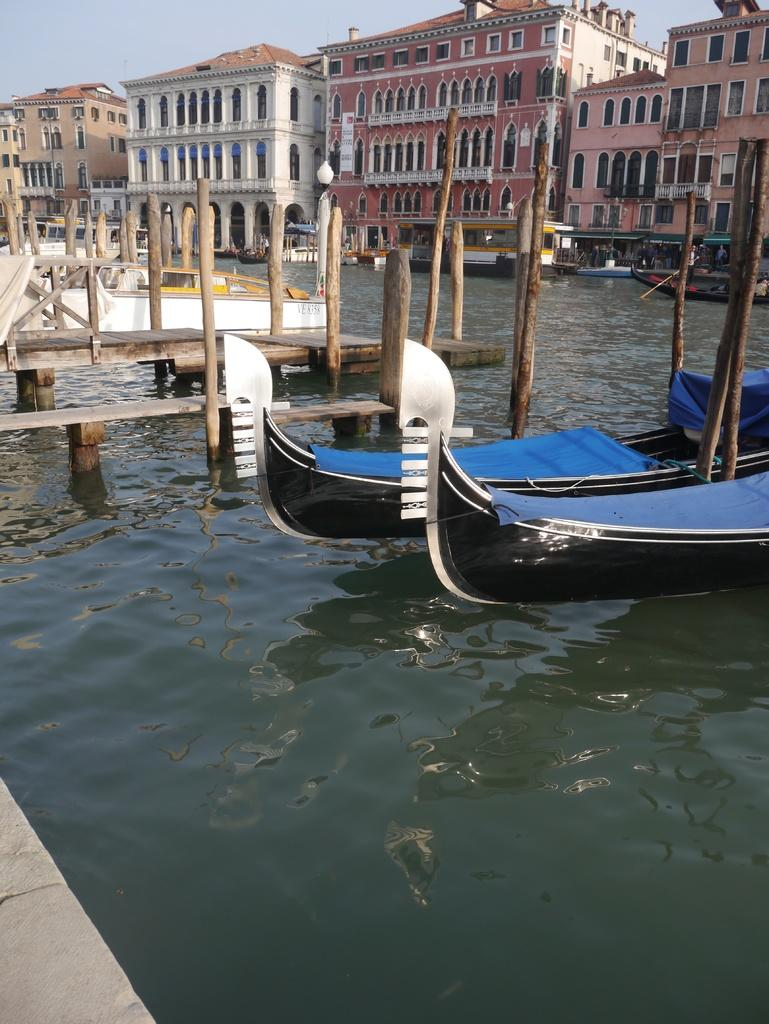What is floating on the water in the image? There are boats floating on the water in the image. What structure can be seen crossing the water in the image? There is a wooden bridge in the image. What can be seen in the distance in the image? There are buildings visible in the background of the image. What else is visible in the background of the image? The sky is visible in the background of the image. What type of loaf is being used to measure the distance between the boats in the image? There is no loaf present in the image, and no measurement is being taken between the boats. How many clocks can be seen hanging on the buildings in the image? There are no clocks visible on the buildings in the image. 